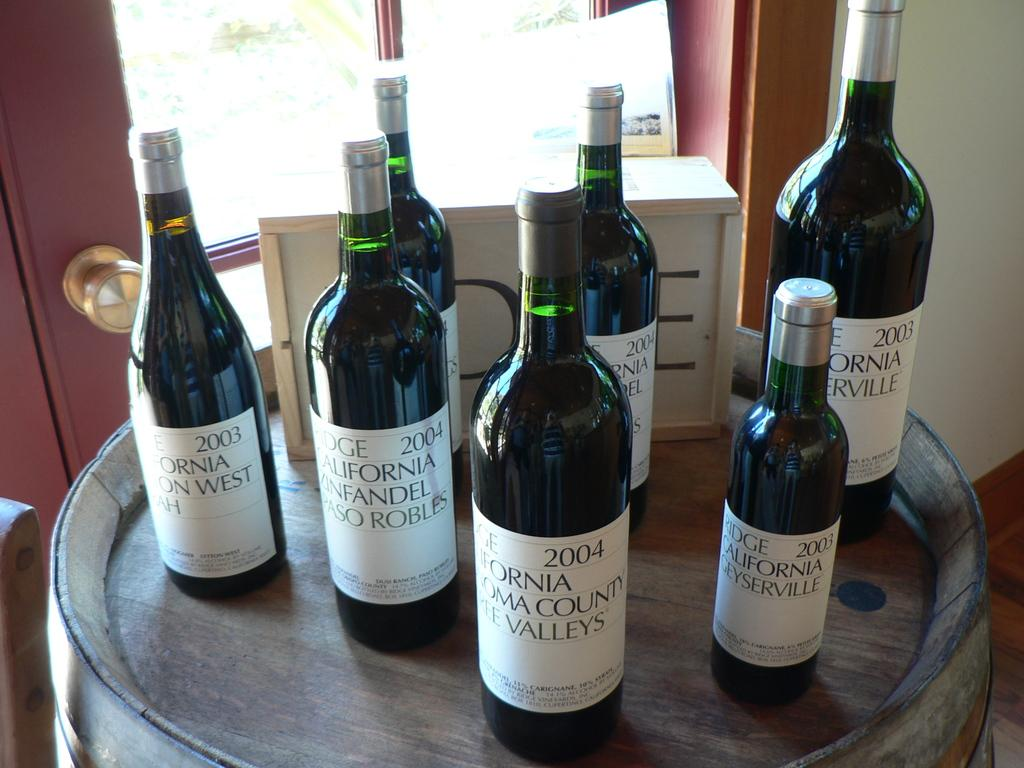<image>
Relay a brief, clear account of the picture shown. Bottles of wine from 2004 and 2003 sit on a table. 